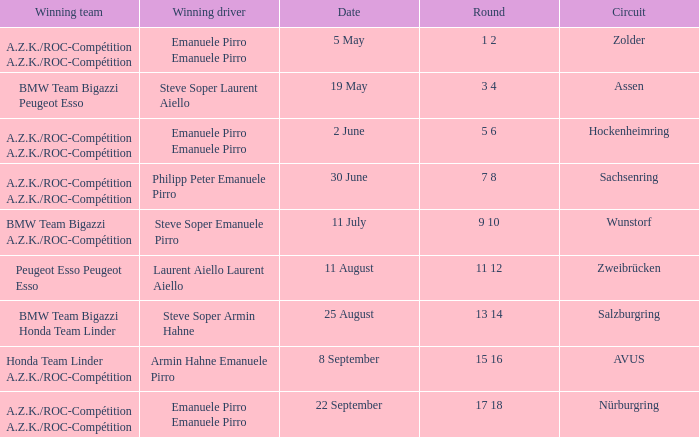What is the date of the zolder circuit, which had a.z.k./roc-compétition a.z.k./roc-compétition as the winning team? 5 May. 